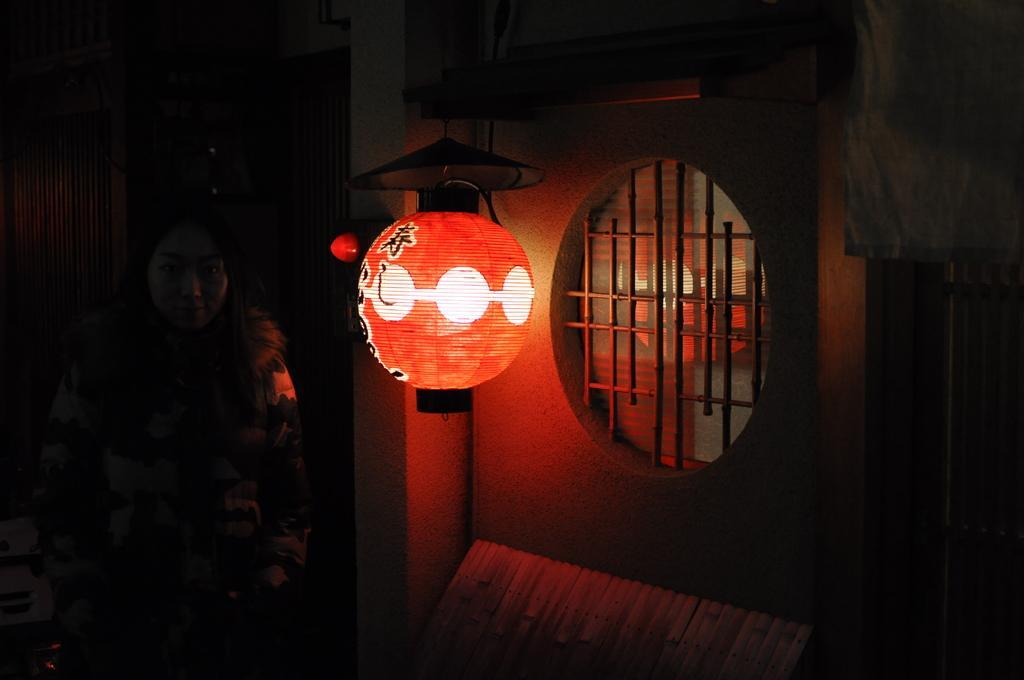Could you give a brief overview of what you see in this image? This image consists of a light. On the right, we can see a window. On the left, there is a woman. And the background is dark. 